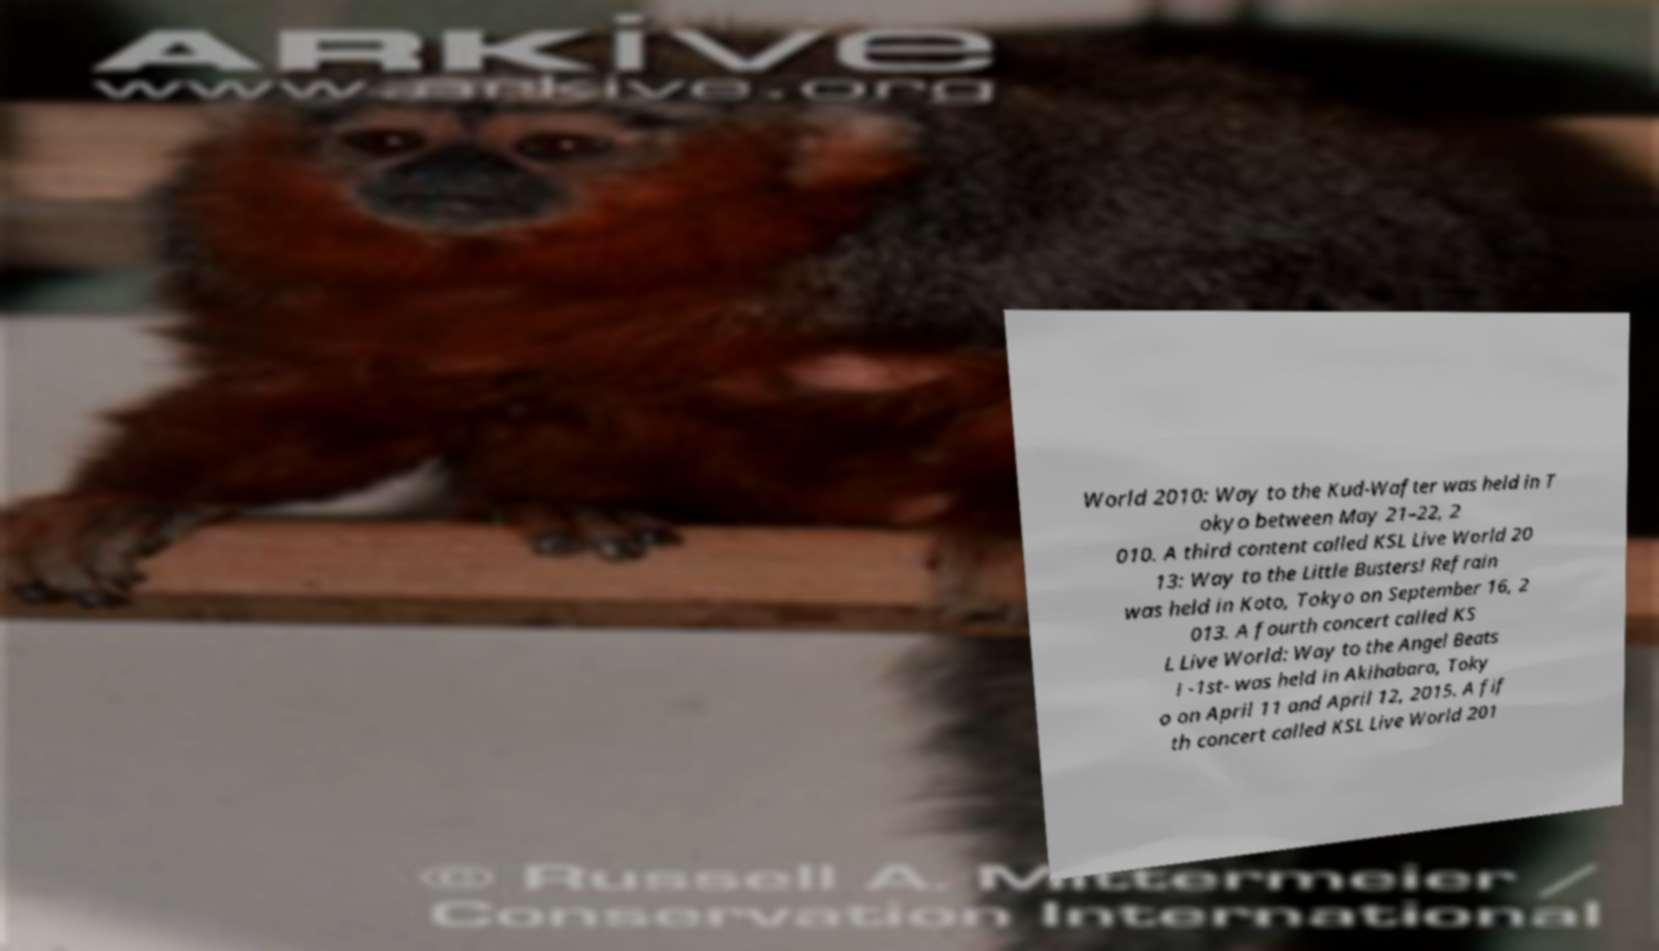Please read and relay the text visible in this image. What does it say? World 2010: Way to the Kud-Wafter was held in T okyo between May 21–22, 2 010. A third content called KSL Live World 20 13: Way to the Little Busters! Refrain was held in Koto, Tokyo on September 16, 2 013. A fourth concert called KS L Live World: Way to the Angel Beats ! -1st- was held in Akihabara, Toky o on April 11 and April 12, 2015. A fif th concert called KSL Live World 201 